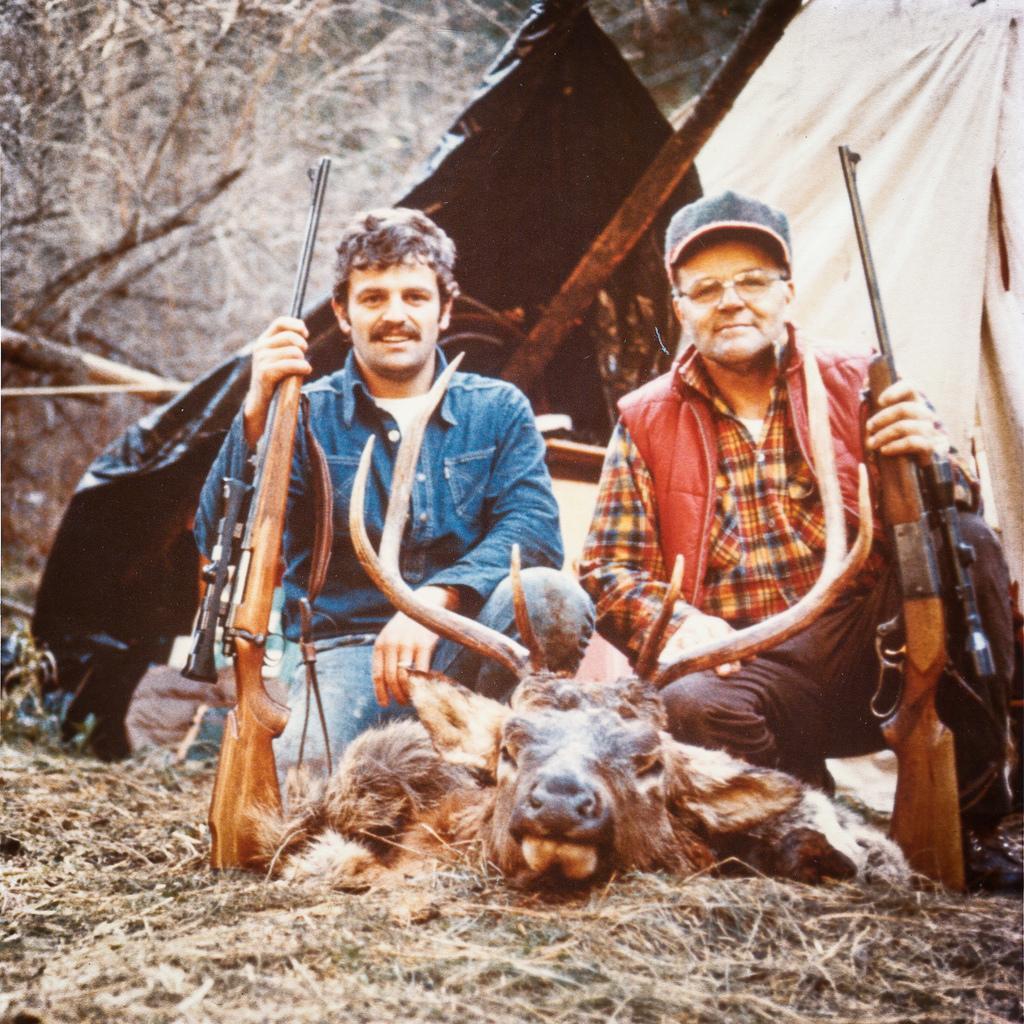Please provide a concise description of this image. In this image I can see there are persons holding a gun. And in front there is a wild animal on the ground. And at the back there it looks like a tent and trees. 